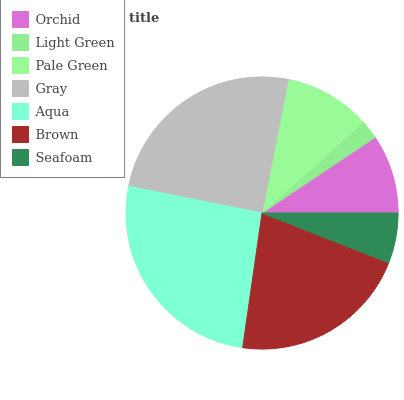Is Light Green the minimum?
Answer yes or no. Yes. Is Aqua the maximum?
Answer yes or no. Yes. Is Pale Green the minimum?
Answer yes or no. No. Is Pale Green the maximum?
Answer yes or no. No. Is Pale Green greater than Light Green?
Answer yes or no. Yes. Is Light Green less than Pale Green?
Answer yes or no. Yes. Is Light Green greater than Pale Green?
Answer yes or no. No. Is Pale Green less than Light Green?
Answer yes or no. No. Is Pale Green the high median?
Answer yes or no. Yes. Is Pale Green the low median?
Answer yes or no. Yes. Is Orchid the high median?
Answer yes or no. No. Is Orchid the low median?
Answer yes or no. No. 